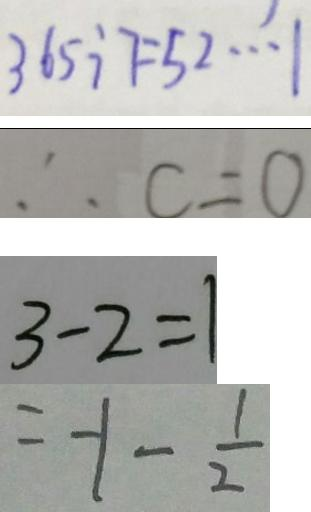<formula> <loc_0><loc_0><loc_500><loc_500>3 6 5 \div 7 = 5 2 \cdots 1 
 \therefore c = 0 
 3 - 2 = 1 
 = - 1 - \frac { 1 } { 2 }</formula> 